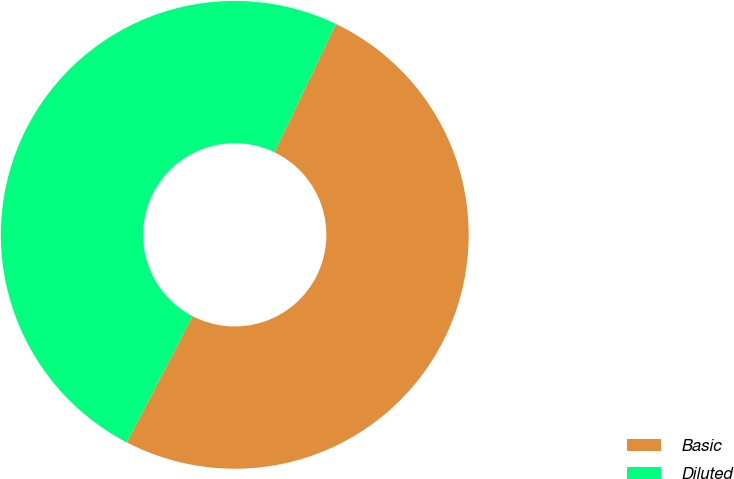<chart> <loc_0><loc_0><loc_500><loc_500><pie_chart><fcel>Basic<fcel>Diluted<nl><fcel>50.51%<fcel>49.49%<nl></chart> 